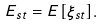<formula> <loc_0><loc_0><loc_500><loc_500>E _ { s t } = E [ \xi _ { s t } ] .</formula> 